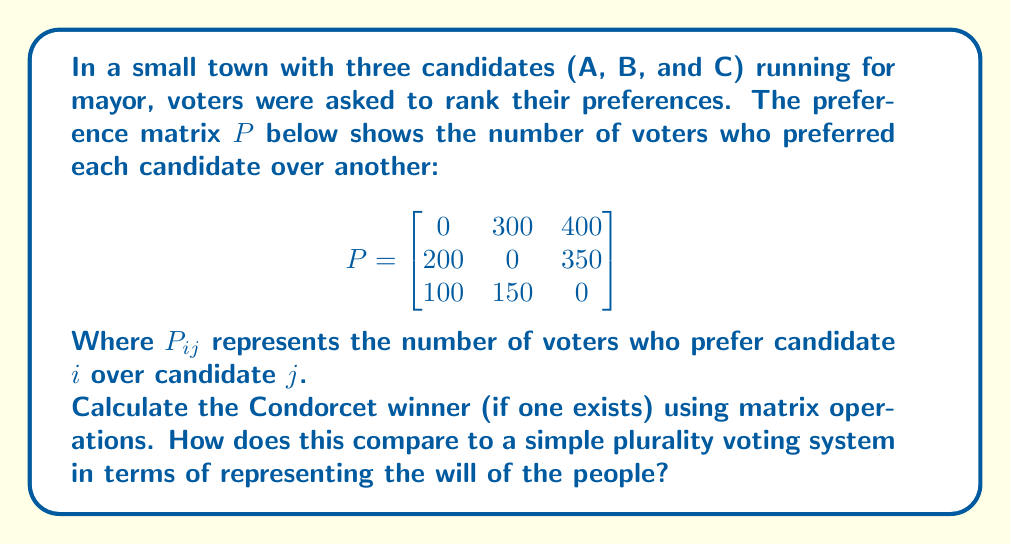Can you solve this math problem? To solve this problem, we'll follow these steps:

1) First, let's understand what the Condorcet winner is. It's the candidate who would win a two-candidate election against each of the other candidates.

2) To find the Condorcet winner using matrix operations, we need to compare each candidate's row with the corresponding column:

   For candidate A: 
   $300 > 200$ and $400 > 100$
   
   For candidate B:
   $200 < 300$ and $350 > 150$
   
   For candidate C:
   $100 < 400$ and $150 < 350$

3) We can represent this comparison in a new matrix $W$:

   $$W = \begin{bmatrix}
   0 & 1 & 1 \\
   0 & 0 & 1 \\
   0 & 0 & 0
   \end{bmatrix}$$

   Where 1 indicates a win and 0 indicates a loss or tie.

4) The Condorcet winner, if one exists, will have all 1's in their row (excluding the diagonal).

5) We can see that candidate A has all 1's in their row, so A is the Condorcet winner.

6) To compare with a plurality voting system, we sum the columns of the original preference matrix:

   A: $200 + 100 = 300$
   B: $300 + 150 = 450$
   C: $400 + 350 = 750$

   Under a plurality system, C would win with 750 votes.

7) The Condorcet method considers the pairwise preferences of all voters, potentially providing a more nuanced representation of voter preferences. In this case, it shows that while C might be the most popular first choice, A is preferred over both other candidates in head-to-head comparisons.

This demonstrates how different voting systems can yield different results, highlighting the importance of choosing a system that best represents the will of the people.
Answer: Candidate A is the Condorcet winner. Plurality voting would elect candidate C instead, potentially misrepresenting overall voter preferences. 